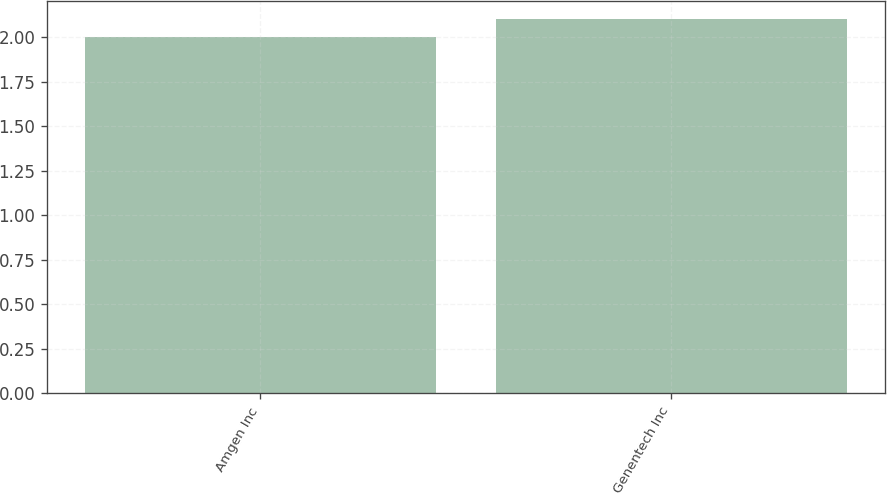Convert chart to OTSL. <chart><loc_0><loc_0><loc_500><loc_500><bar_chart><fcel>Amgen Inc<fcel>Genentech Inc<nl><fcel>2<fcel>2.1<nl></chart> 